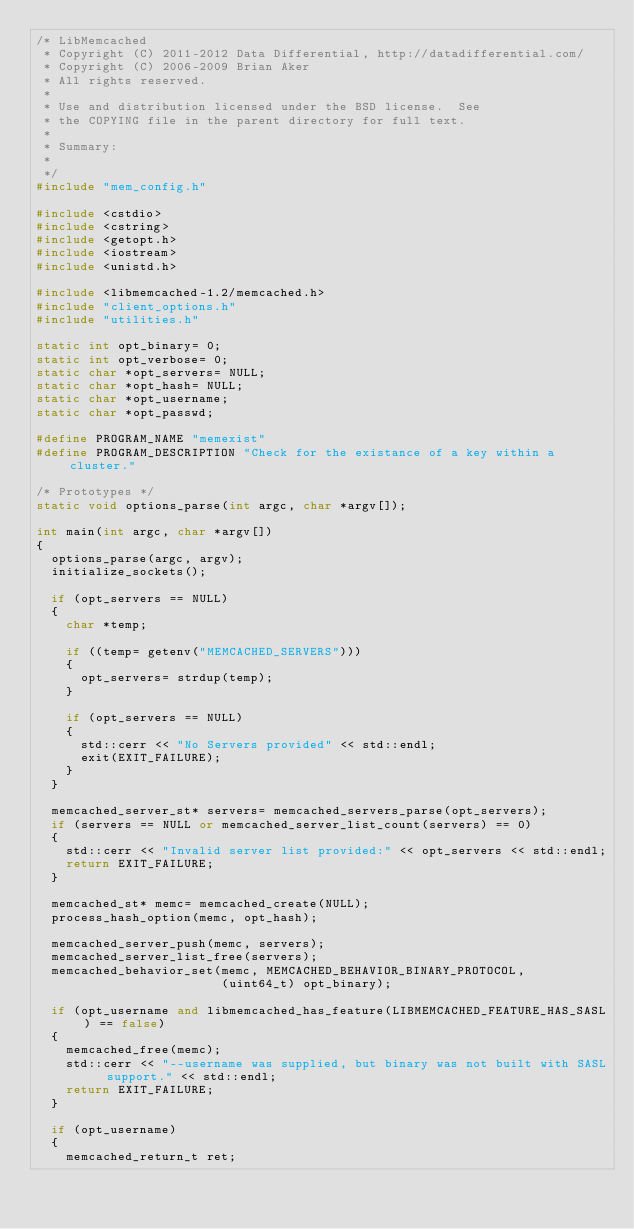<code> <loc_0><loc_0><loc_500><loc_500><_C++_>/* LibMemcached
 * Copyright (C) 2011-2012 Data Differential, http://datadifferential.com/
 * Copyright (C) 2006-2009 Brian Aker
 * All rights reserved.
 *
 * Use and distribution licensed under the BSD license.  See
 * the COPYING file in the parent directory for full text.
 *
 * Summary:
 *
 */
#include "mem_config.h"

#include <cstdio>
#include <cstring>
#include <getopt.h>
#include <iostream>
#include <unistd.h>

#include <libmemcached-1.2/memcached.h>
#include "client_options.h"
#include "utilities.h"

static int opt_binary= 0;
static int opt_verbose= 0;
static char *opt_servers= NULL;
static char *opt_hash= NULL;
static char *opt_username;
static char *opt_passwd;

#define PROGRAM_NAME "memexist"
#define PROGRAM_DESCRIPTION "Check for the existance of a key within a cluster."

/* Prototypes */
static void options_parse(int argc, char *argv[]);

int main(int argc, char *argv[])
{
  options_parse(argc, argv);
  initialize_sockets();

  if (opt_servers == NULL)
  {
    char *temp;

    if ((temp= getenv("MEMCACHED_SERVERS")))
    {
      opt_servers= strdup(temp);
    }

    if (opt_servers == NULL)
    {
      std::cerr << "No Servers provided" << std::endl;
      exit(EXIT_FAILURE);
    }
  }

  memcached_server_st* servers= memcached_servers_parse(opt_servers);
  if (servers == NULL or memcached_server_list_count(servers) == 0)
  {
    std::cerr << "Invalid server list provided:" << opt_servers << std::endl;
    return EXIT_FAILURE;
  }

  memcached_st* memc= memcached_create(NULL);
  process_hash_option(memc, opt_hash);

  memcached_server_push(memc, servers);
  memcached_server_list_free(servers);
  memcached_behavior_set(memc, MEMCACHED_BEHAVIOR_BINARY_PROTOCOL,
                         (uint64_t) opt_binary);

  if (opt_username and libmemcached_has_feature(LIBMEMCACHED_FEATURE_HAS_SASL) == false)
  {
    memcached_free(memc);
    std::cerr << "--username was supplied, but binary was not built with SASL support." << std::endl;
    return EXIT_FAILURE;
  }

  if (opt_username)
  {
    memcached_return_t ret;</code> 